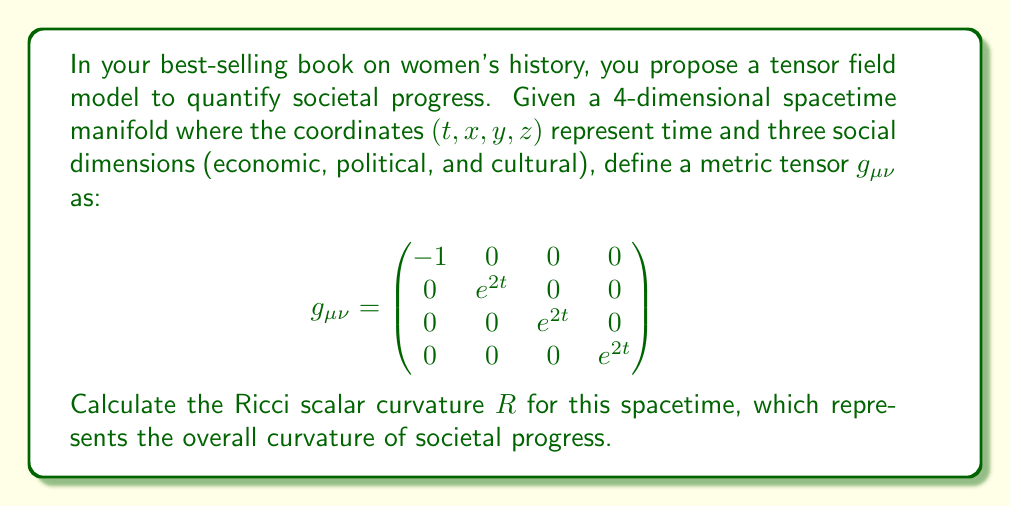Help me with this question. To calculate the Ricci scalar curvature, we need to follow these steps:

1) First, calculate the Christoffel symbols $\Gamma^{\lambda}_{\mu\nu}$ using the metric tensor:

   $$\Gamma^{\lambda}_{\mu\nu} = \frac{1}{2}g^{\lambda\sigma}(\partial_{\mu}g_{\sigma\nu} + \partial_{\nu}g_{\sigma\mu} - \partial_{\sigma}g_{\mu\nu})$$

   The non-zero Christoffel symbols are:
   $$\Gamma^{i}_{ti} = \Gamma^{i}_{it} = 1 \quad \text{for} \quad i = 1,2,3$$

2) Next, calculate the Riemann curvature tensor:

   $$R^{\rho}_{\sigma\mu\nu} = \partial_{\mu}\Gamma^{\rho}_{\sigma\nu} - \partial_{\nu}\Gamma^{\rho}_{\sigma\mu} + \Gamma^{\rho}_{\lambda\mu}\Gamma^{\lambda}_{\sigma\nu} - \Gamma^{\rho}_{\lambda\nu}\Gamma^{\lambda}_{\sigma\mu}$$

   The non-zero components are:
   $$R^{i}_{tit} = -1 \quad \text{for} \quad i = 1,2,3$$

3) Contract the Riemann tensor to get the Ricci tensor:

   $$R_{\mu\nu} = R^{\lambda}_{\mu\lambda\nu}$$

   The non-zero components are:
   $$R_{tt} = -3, \quad R_{ii} = e^{2t} \quad \text{for} \quad i = 1,2,3$$

4) Finally, contract the Ricci tensor with the inverse metric to get the Ricci scalar:

   $$R = g^{\mu\nu}R_{\mu\nu}$$

   $$R = g^{tt}R_{tt} + g^{11}R_{11} + g^{22}R_{22} + g^{33}R_{33}$$
   $$R = (-1)(-3) + (e^{-2t})(e^{2t}) + (e^{-2t})(e^{2t}) + (e^{-2t})(e^{2t})$$
   $$R = 3 + 1 + 1 + 1 = 6$$

Therefore, the Ricci scalar curvature $R$, representing the overall curvature of societal progress in this model, is 6.
Answer: $R = 6$ 